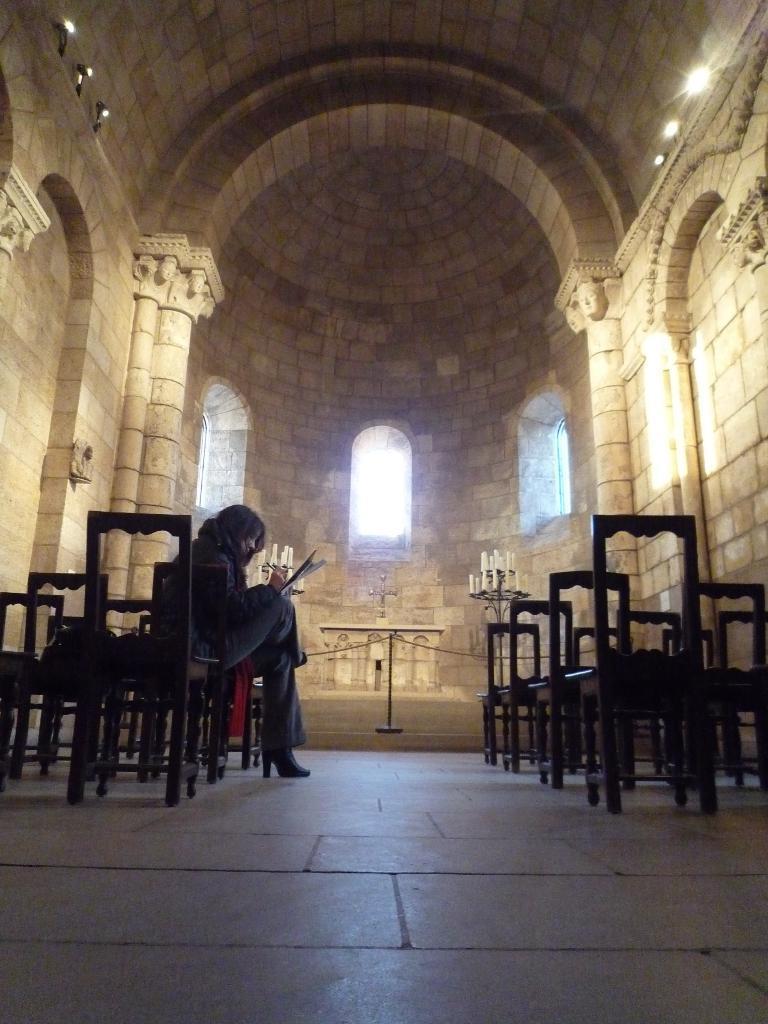Can you describe this image briefly? In a room there are many chairs. To the left side there is a lady sitting on a chair. And on the other side there are pillars. It looks like an arch. And to the both side of the cross symbol there are candles. And there are some windows. 